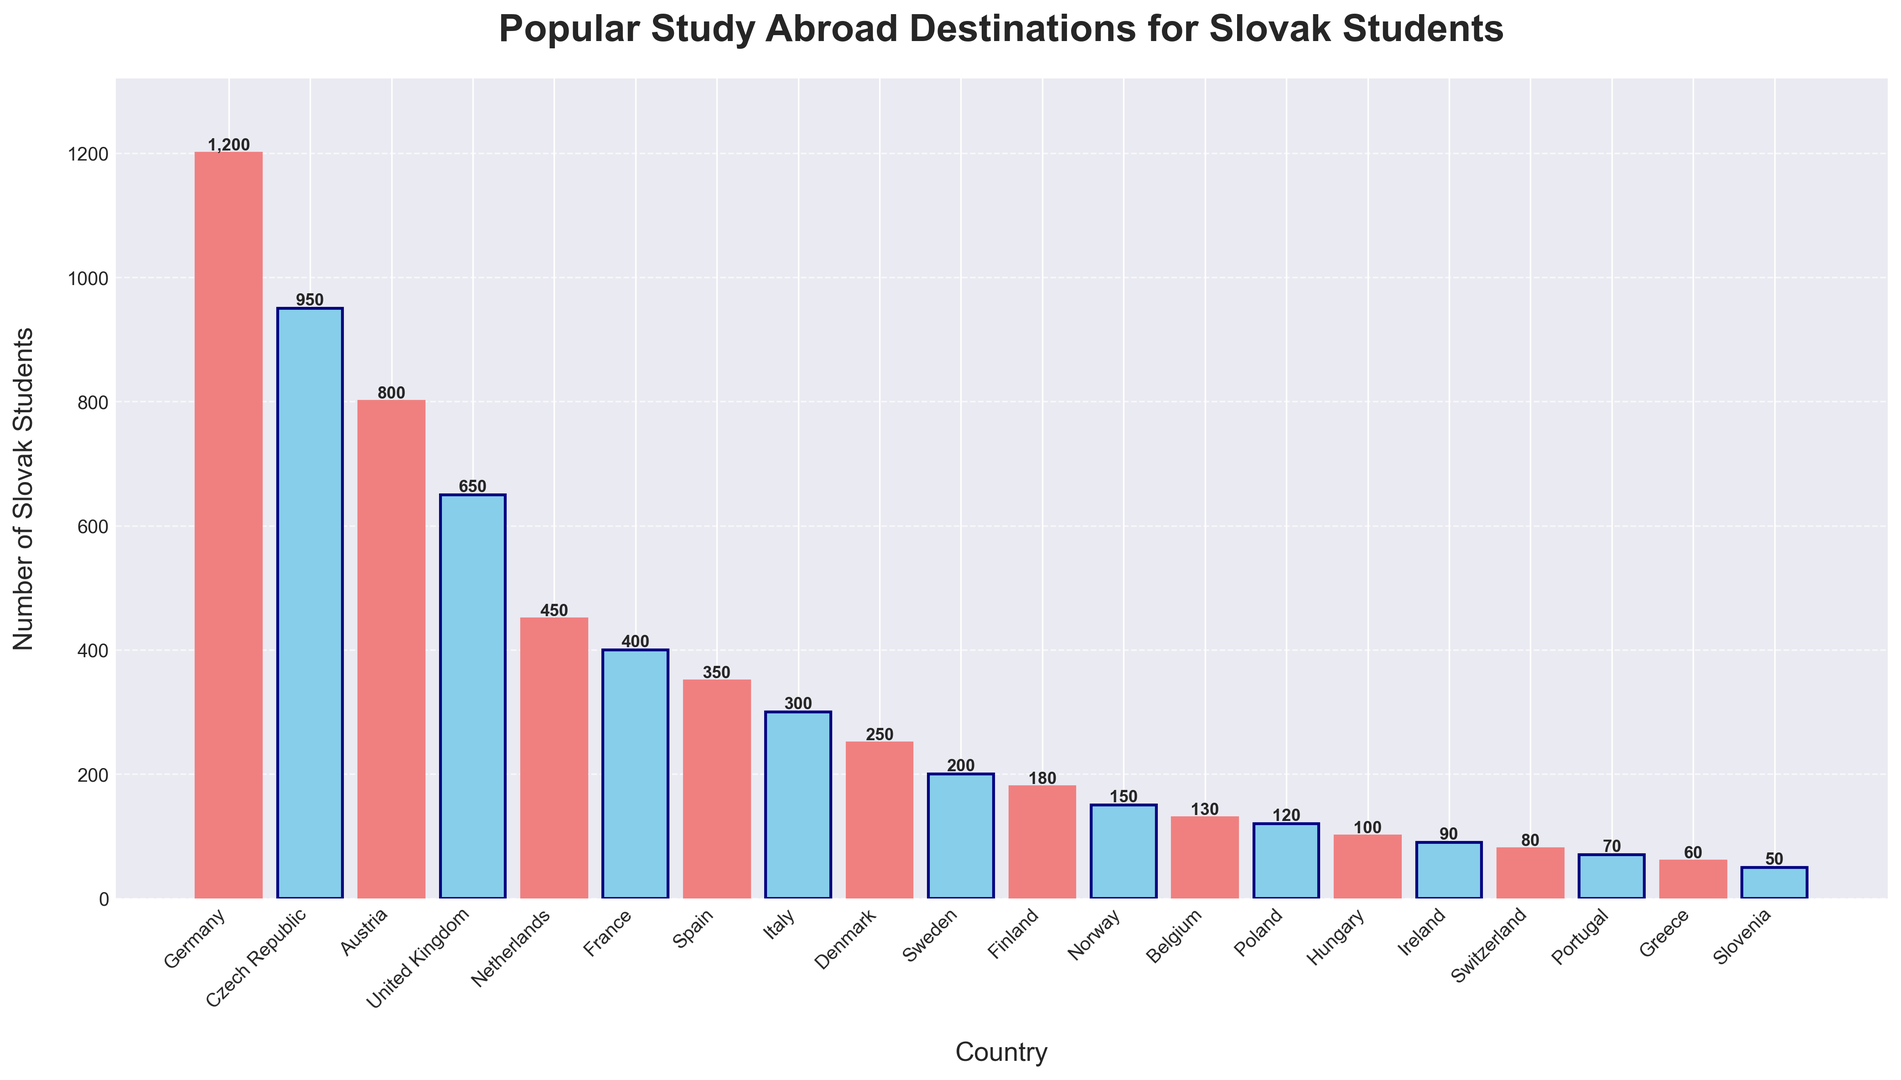Which country has the highest number of Slovak students studying abroad? The figure shows that Germany has the tallest bar among all countries. Hence, Germany has the highest number of Slovak students studying abroad.
Answer: Germany What is the total number of Slovak students studying in Germany and the Czech Republic? Germany has 1200 students and the Czech Republic has 950 students. The total is 1200 + 950.
Answer: 2150 Which country has fewer students, Norway or Belgium? Comparing the bars for Norway and Belgium, the bar for Norway is slightly shorter. Norway has 150 students, while Belgium has 130 students. Therefore, Belgium has fewer students.
Answer: Belgium How many more students are studying in Austria than in Spain? Austria has 800 students, and Spain has 350 students. The difference is 800 - 350.
Answer: 450 Which countries have bars colored in lightcoral? According to the pattern, every other bar is colored lightcoral starting from Germany. Thus, the countries with lightcoral bars are Germany, Austria, Netherlands, Spain, Denmark, Finland, Belgium, Hungary, Switzerland, and Greece.
Answer: Germany, Austria, Netherlands, Spain, Denmark, Finland, Belgium, Hungary, Switzerland, Greece What is the average number of Slovak students studying in the top three countries? The top three countries by the number of Slovak students are Germany (1200), Czech Republic (950), and Austria (800). The average is (1200 + 950 + 800) / 3.
Answer: 983.33 Which country has the least number of Slovak students studying abroad? The smallest bar on the figure represents Slovenia. Thus, Slovenia has the least number of Slovak students.
Answer: Slovenia Is the number of Slovak students in Italy greater than the number in Sweden? From the figure, the bar for Italy is taller than the bar for Sweden. Hence, the number of Slovak students in Italy (300) is greater than in Sweden (200).
Answer: Yes What is the sum of Slovak students studying in France, Spain, and Italy? France has 400, Spain has 350, and Italy has 300 students. The sum is 400 + 350 + 300.
Answer: 1050 How many countries have more than 500 Slovak students studying abroad? The countries with more than 500 students are Germany (1200), Czech Republic (950), Austria (800), and the United Kingdom (650). Therefore, there are 4 such countries.
Answer: 4 